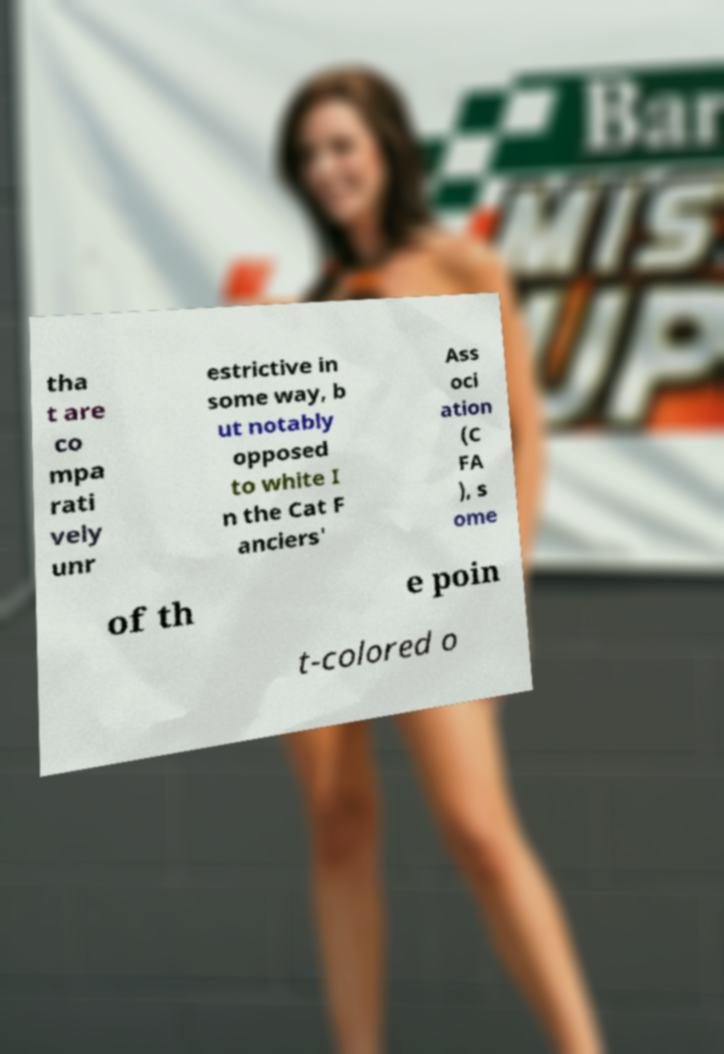Please identify and transcribe the text found in this image. tha t are co mpa rati vely unr estrictive in some way, b ut notably opposed to white I n the Cat F anciers' Ass oci ation (C FA ), s ome of th e poin t-colored o 